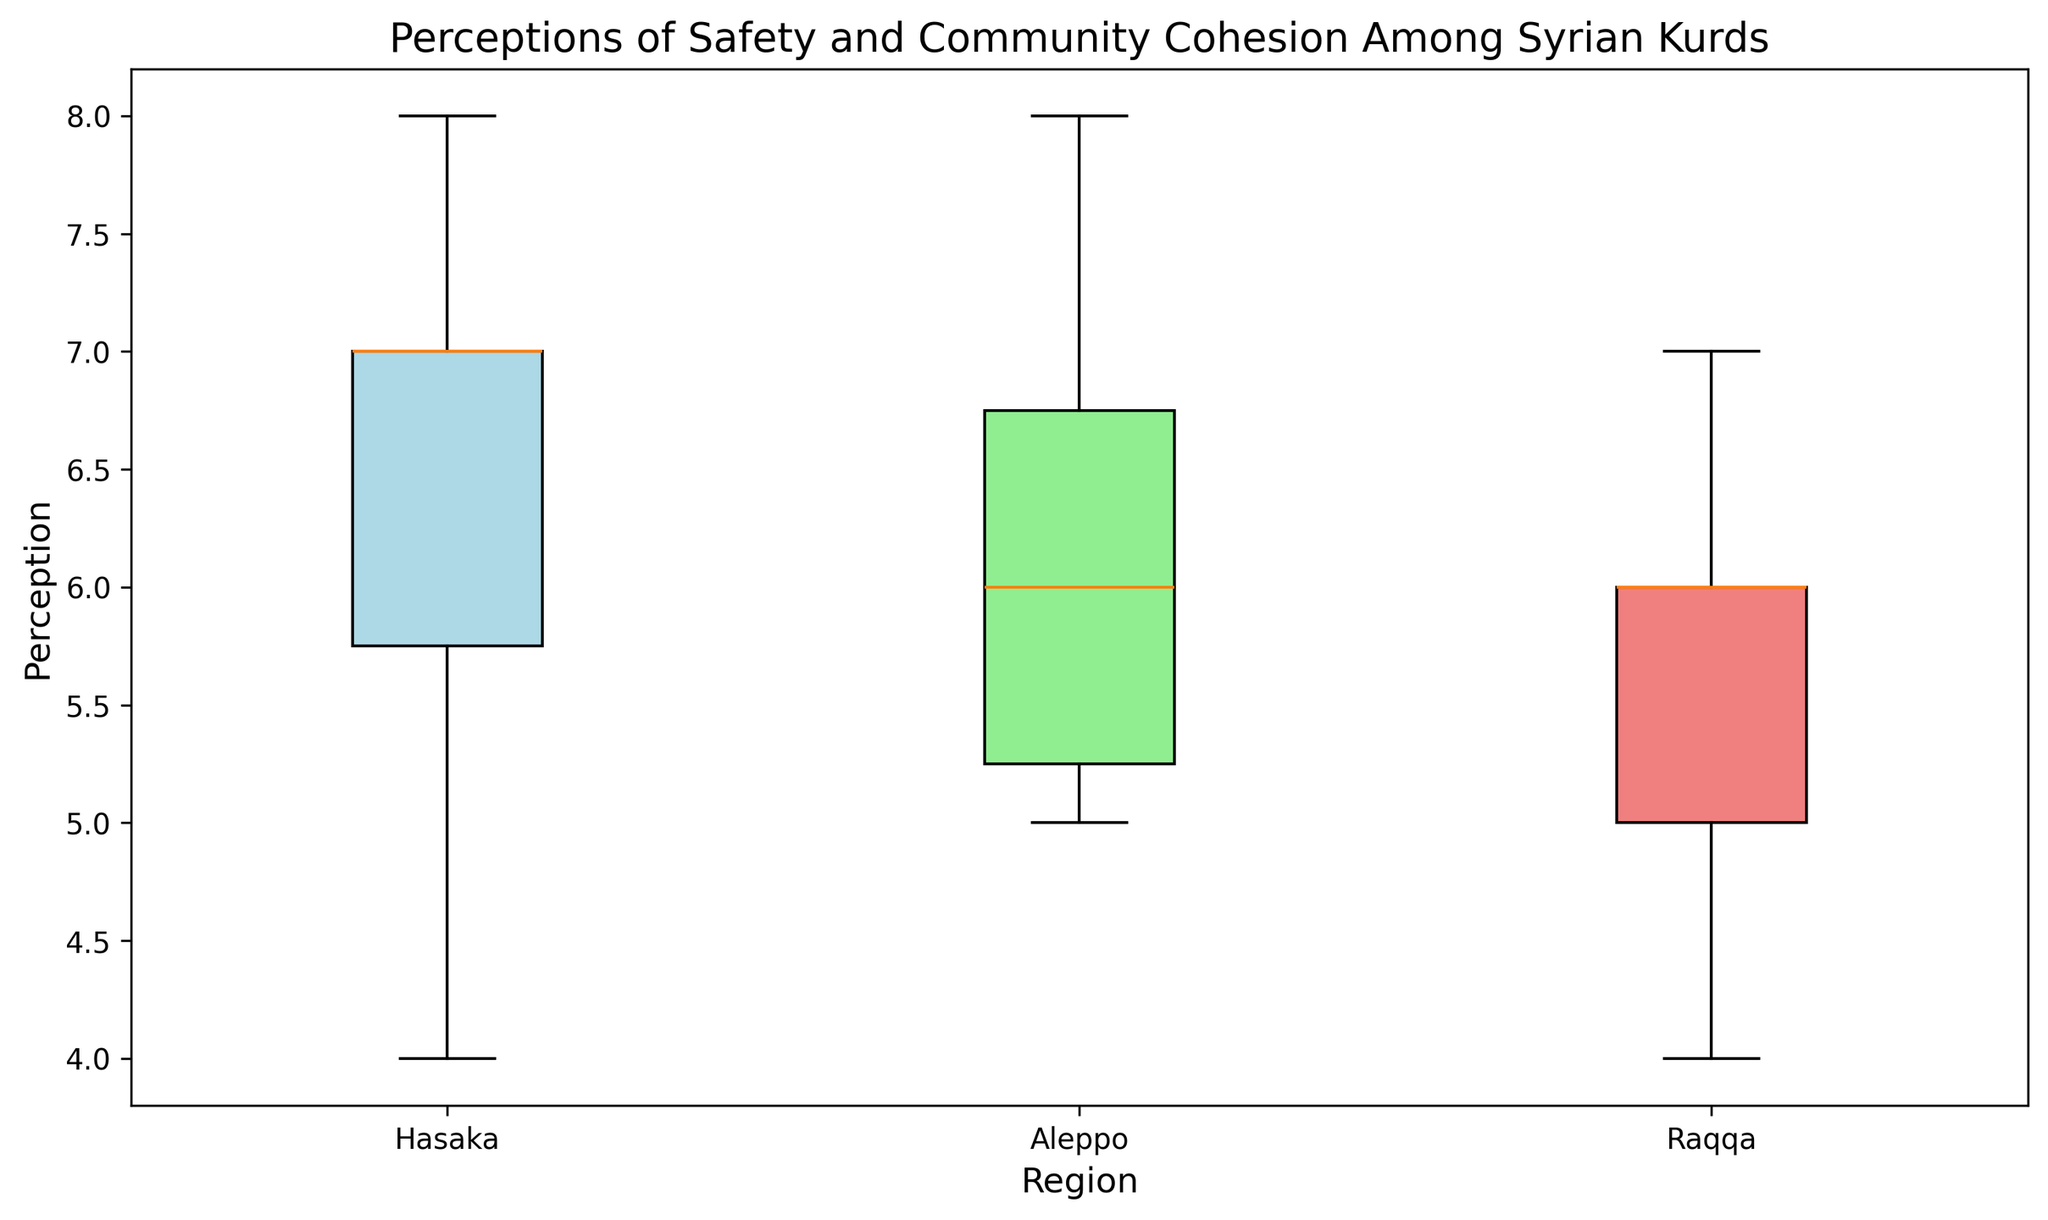What region has the highest median perception of safety? To find the region with the highest median perception, look at the center line within each boxplot. The region with the highest center line is Aleppo.
Answer: Aleppo Which region has the greatest spread in perceptions? The spread can be assessed by looking at the range between the top and bottom edges of the boxes (interquartile range) as well as the "whiskers" that extend from the boxes. Hasaka has the largest spread across the entire range of perceptions.
Answer: Hasaka What is the median perception for Raqqa? To find the median perception for Raqqa, look for the middle line in the Raqqa boxplot. The median is 6.
Answer: 6 Which region has the lowest minimum perception value, and what is that value? The minimum perception value can be determined by looking at the bottom whisker of the boxplots. Raqqa has the lowest minimum value, which is 4.
Answer: Raqqa, 4 Which region has more consistent perceptions, Aleppo or Raqqa? Consistency can be judged by the spread of the perceptions. Aleppo has a smaller range compared to Raqqa, indicating more consistency.
Answer: Aleppo Compare the upper quartile values for Hasaka and Aleppo. Which is higher? The upper quartile value is indicated by the top edge of the box. Hasaka's upper quartile is higher than Aleppo's.
Answer: Hasaka What is the interquartile range (IQR) for Aleppo? The IQR is the range between the upper quartile (75th percentile) and the lower quartile (25th percentile). For Aleppo, the lower quartile is 6 and the upper quartile is 7, so the IQR is 7 - 6 = 1.
Answer: 1 Is the median perception value for Hasaka greater than the upper quartile value for Raqqa? The median value for Hasaka is at the center line, which is 7. The upper quartile for Raqqa is the top edge of the box, which is 6. Since 7 is greater than 6, the median for Hasaka is higher.
Answer: Yes Which color patch corresponds to the boxplot for Raqqa? The boxplot color refers to each region's box. The patch color for Raqqa is light coral.
Answer: Light coral 